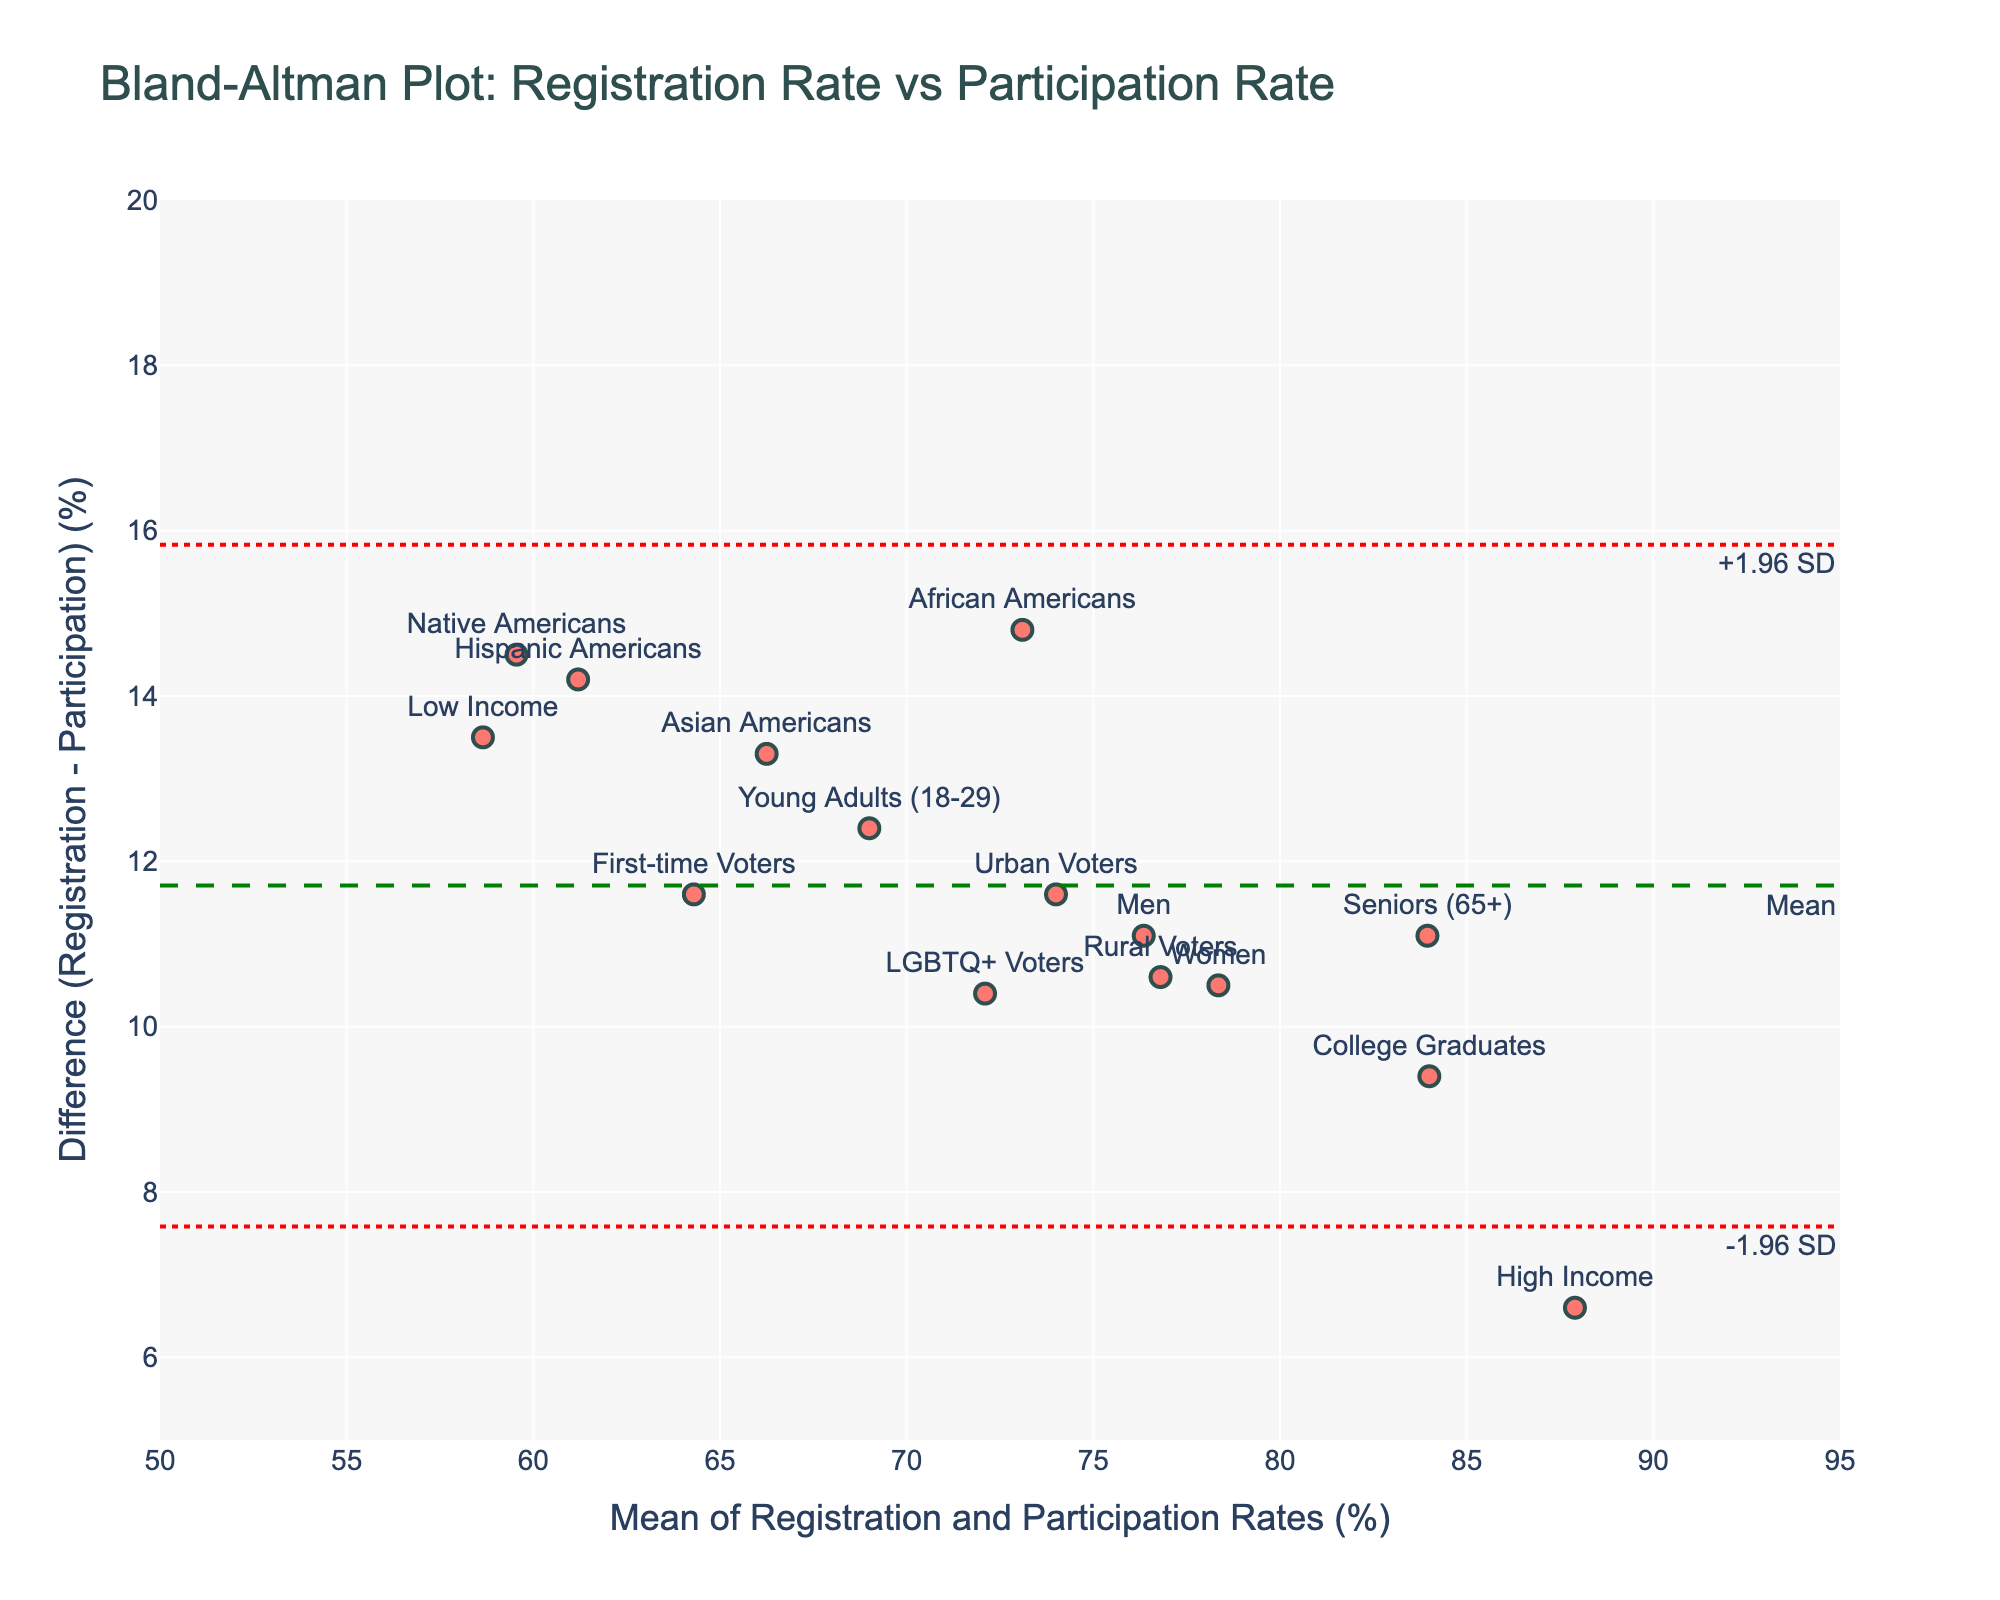What is the title of the plot? The title of the plot is typically displayed at the top center of the figure. By directly referring to the figure, we can see the text for the title.
Answer: Bland-Altman Plot: Registration Rate vs Participation Rate How many data points are plotted? You can count the number of markers (dots) in the scatter plot to determine the number of data points.
Answer: 15 What does the y-axis represent in this plot? The y-axis label provides information about what is being measured. In this case, it shows "Difference (Registration - Participation) (%)", which means it represents the difference between the registration and participation rates.
Answer: Difference (Registration - Participation) (%) Which voter group shows the smallest difference between registration and participation rates? By identifying the data point with the smallest y-value (the closest to zero) and checking the text labels adjacent to the markers, we can find the voter group.
Answer: High Income What is the mean difference between registration and participation rates? The mean difference is indicated by a horizontal dashed line labeled "Mean". It can be found by following the dashed line to the y-axis.
Answer: Around 14.2 What are the upper and lower limits of agreement? The upper and lower limits of agreement are indicated by dotted lines labeled "+1.96 SD" and "-1.96 SD", respectively. By checking the values where these dotted lines intersect the y-axis, we can determine the limits.
Answer: Upper: Around 18.63, Lower: Around 9.77 Which voter group has the largest difference between registration and participation rates? Look for the highest point on the y-axis and check the corresponding text label near the marker to identify the voter group with the largest positive difference.
Answer: High Income How many voter groups fall outside the limits of agreement (upper or lower)? Count the data points that lie above the upper dotted line or below the lower dotted line. By visually checking the positions of markers relative to these lines, we can determine the number.
Answer: 0 What is the average mean value of voter registration and participation rates? To find the average mean value, calculate the mean of the mean values (x-coordinates of data points).
Answer: (75.2+80.5+68.3+72.9+88.7+82.1+79.8+65.4+91.2+83.6+81.9+89.5+66.8+77.3+70.1)/15 = 78.3 Which voter group has a higher mean value between 'Young Adults (18-29)' and 'Seniors (65+)'? Compare the x-values (mean values of registration and participation rates) for 'Young Adults (18-29)' and 'Seniors (65+)' to see which is higher.
Answer: Seniors (65+) 